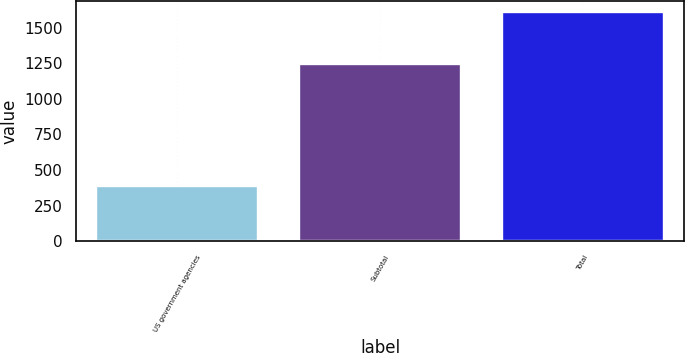Convert chart to OTSL. <chart><loc_0><loc_0><loc_500><loc_500><bar_chart><fcel>US government agencies<fcel>Subtotal<fcel>Total<nl><fcel>389.2<fcel>1242.7<fcel>1608.9<nl></chart> 